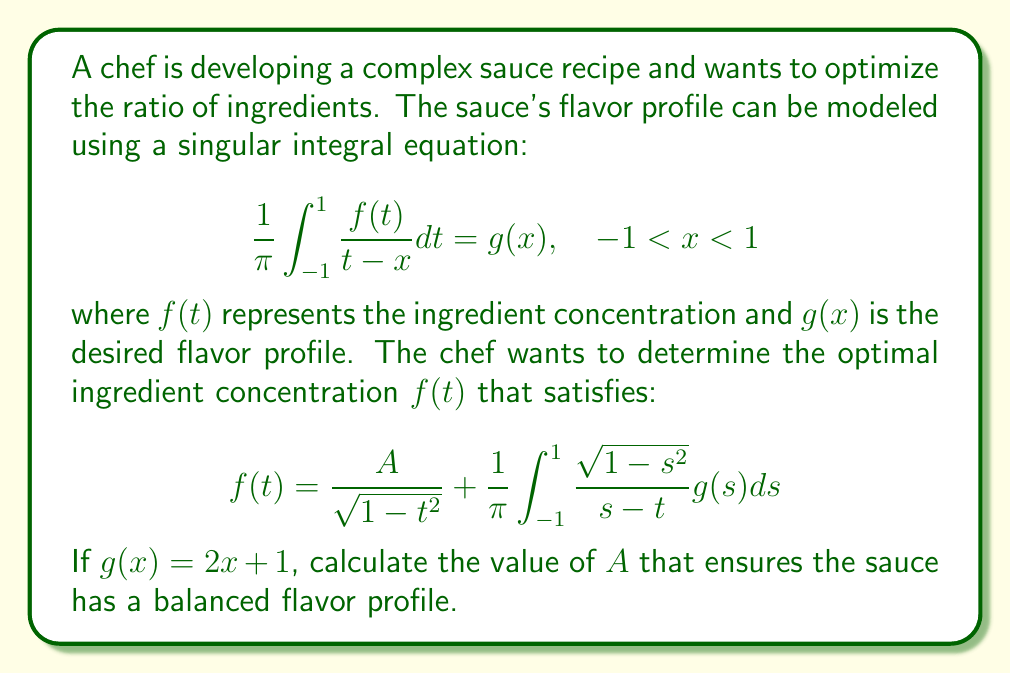Give your solution to this math problem. To solve this problem, we'll follow these steps:

1) First, we recognize that this is a singular integral equation of the first kind, specifically a Cauchy principal value integral.

2) The given solution form is known as the Poincaré-Bertrand formula, which is used to invert singular integral equations.

3) To find $A$, we need to ensure that the solution satisfies the original integral equation. We can do this by substituting the solution back into the original equation.

4) Substituting $f(t)$ into the original equation:

   $$\frac{1}{\pi} \int_{-1}^{1} \frac{1}{t-x} \left(\frac{A}{\sqrt{1-t^2}} + \frac{1}{\pi} \int_{-1}^{1} \frac{\sqrt{1-s^2}}{s-t} g(s) ds\right) dt = g(x)$$

5) Using the properties of singular integrals, we can simplify this:

   $$\frac{A}{\sqrt{1-x^2}} + \frac{1}{\pi} \int_{-1}^{1} \frac{\sqrt{1-s^2}}{s-x} g(s) ds = g(x)$$

6) Now, we substitute $g(x) = 2x + 1$:

   $$\frac{A}{\sqrt{1-x^2}} + \frac{1}{\pi} \int_{-1}^{1} \frac{\sqrt{1-s^2}}{s-x} (2s + 1) ds = 2x + 1$$

7) The integral on the left side can be evaluated using known results for singular integrals:

   $$\frac{A}{\sqrt{1-x^2}} + (2x + 1) = 2x + 1$$

8) Simplifying:

   $$\frac{A}{\sqrt{1-x^2}} = 0$$

9) For this to be true for all $x$ in the interval $(-1, 1)$, we must have $A = 0$.

Therefore, the value of $A$ that ensures a balanced flavor profile is 0.
Answer: $A = 0$ 